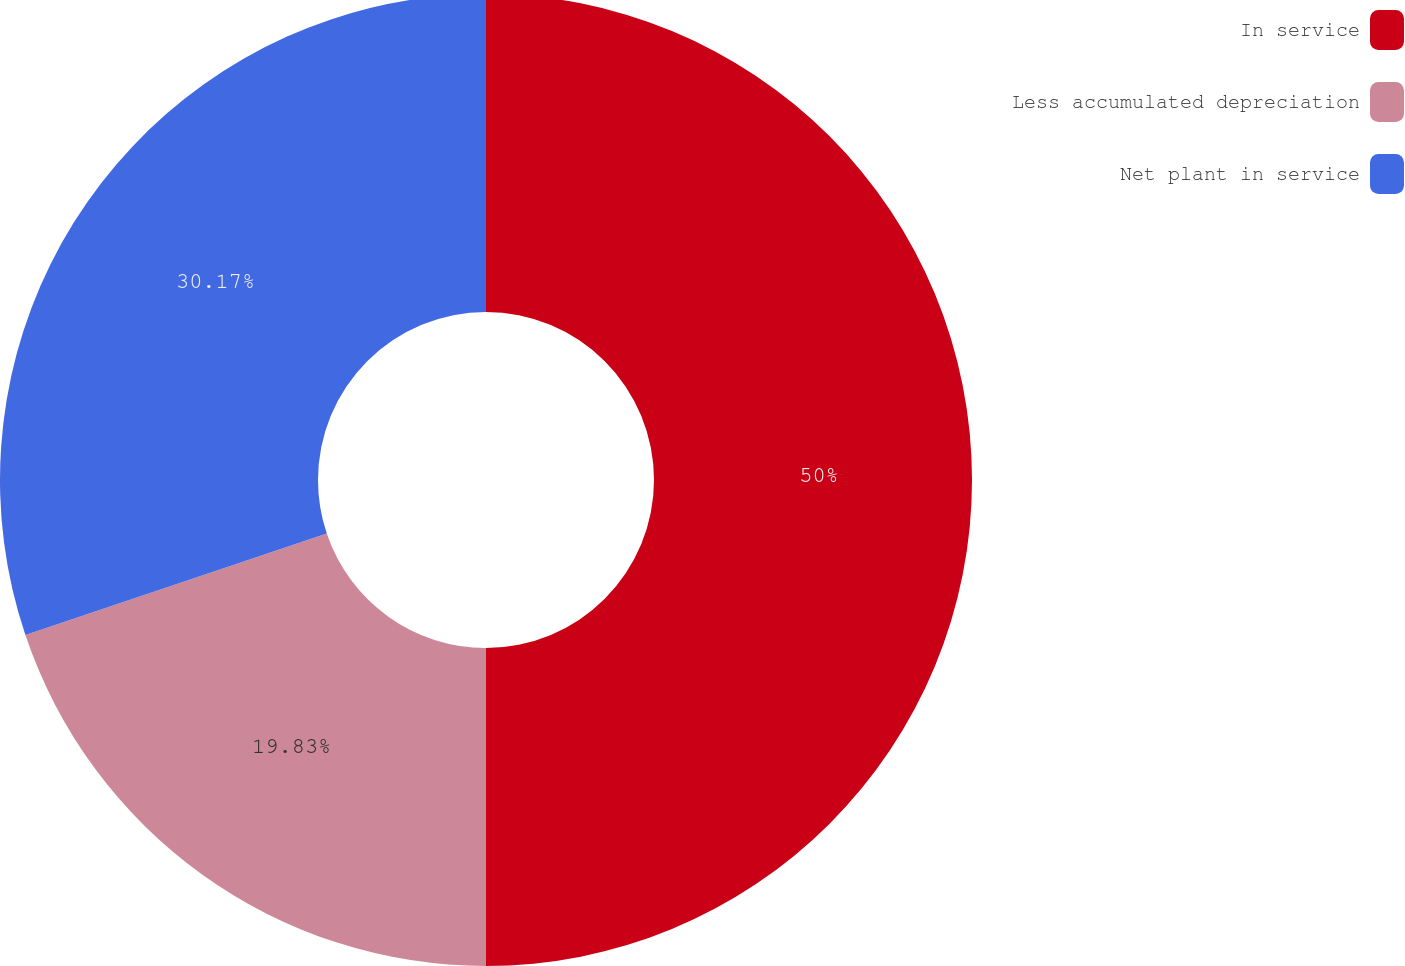Convert chart. <chart><loc_0><loc_0><loc_500><loc_500><pie_chart><fcel>In service<fcel>Less accumulated depreciation<fcel>Net plant in service<nl><fcel>50.0%<fcel>19.83%<fcel>30.17%<nl></chart> 